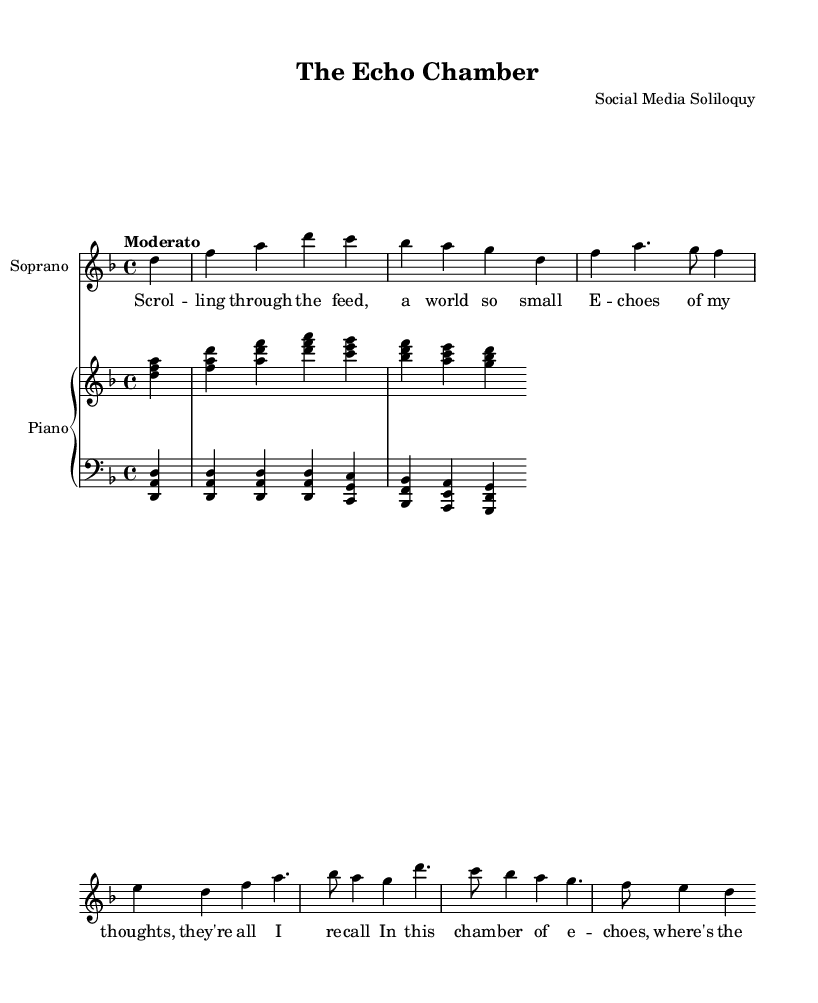What is the key signature of this music? The key signature indicates D minor, which has one flat (B flat). This can be identified in the global music settings where the key is defined.
Answer: D minor What is the time signature of this music? The time signature is 4/4, meaning there are four beats in each measure and a quarter note gets one beat. This is explicitly stated in the global section of the music.
Answer: 4/4 What is the tempo marking for the piece? The tempo marking is "Moderato," which indicates a moderate pace for the music. This is mentioned in the global settings.
Answer: Moderato How many measures are in the provided soprano part? Counting the measures in the soprano part, there are a total of six measures shown. This can be determined by counting the vertical lines that separate the groupings of notes.
Answer: Six What lyrical theme does the chorus suggest? The chorus suggests a theme about searching for truth in a distorted reality, indicated by the lyrics "In this chamber of echoes, where's the truth?"
Answer: Searching for truth What is the structure of the opera as indicated in the music? The opera follows a standard structure of introduction, a verse, and a chorus, clearly laid out in the music with distinct sections. This can be inferred from the labels in the soprano part.
Answer: Introduction, Verse, Chorus 